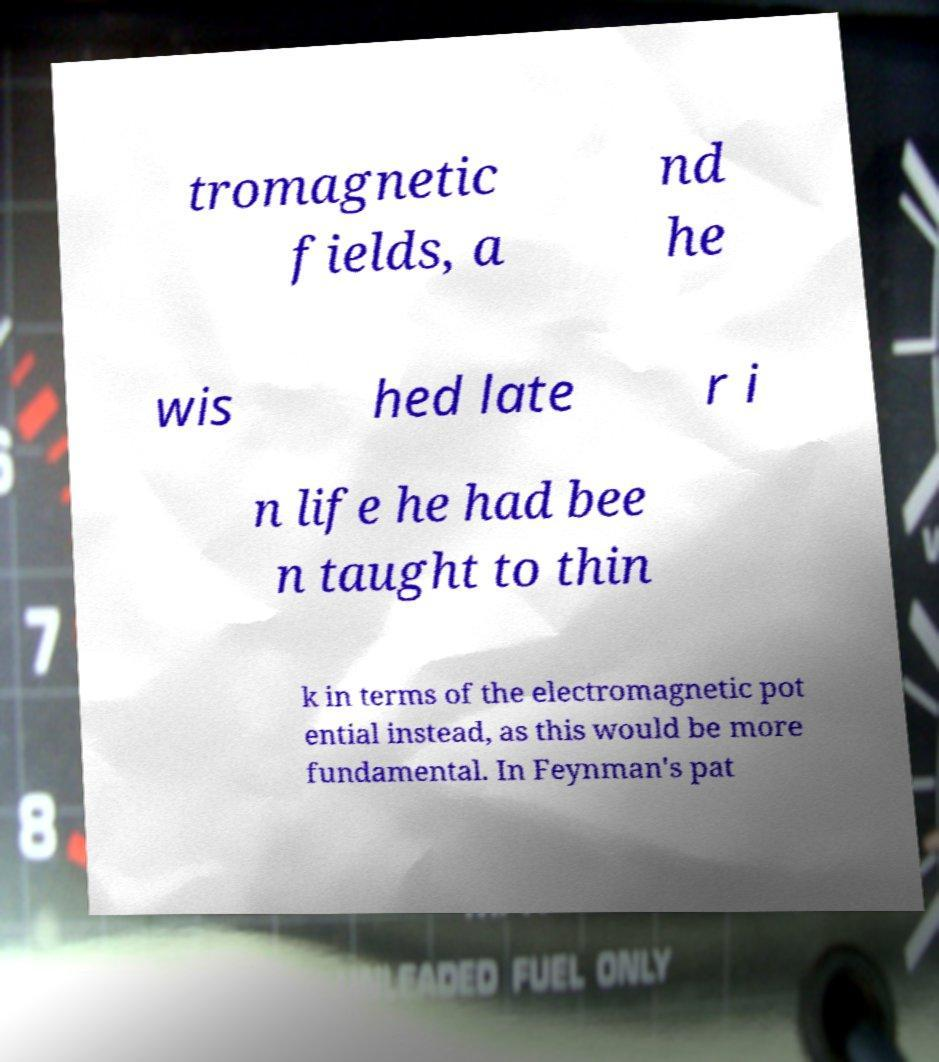Please identify and transcribe the text found in this image. tromagnetic fields, a nd he wis hed late r i n life he had bee n taught to thin k in terms of the electromagnetic pot ential instead, as this would be more fundamental. In Feynman's pat 